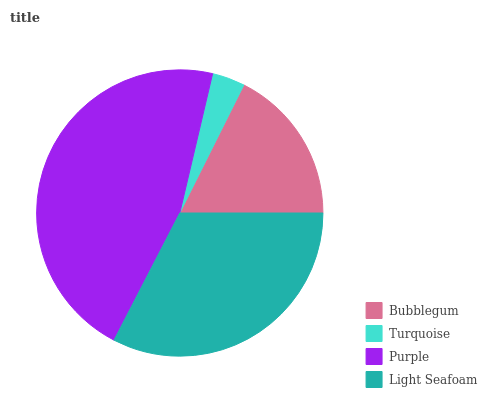Is Turquoise the minimum?
Answer yes or no. Yes. Is Purple the maximum?
Answer yes or no. Yes. Is Purple the minimum?
Answer yes or no. No. Is Turquoise the maximum?
Answer yes or no. No. Is Purple greater than Turquoise?
Answer yes or no. Yes. Is Turquoise less than Purple?
Answer yes or no. Yes. Is Turquoise greater than Purple?
Answer yes or no. No. Is Purple less than Turquoise?
Answer yes or no. No. Is Light Seafoam the high median?
Answer yes or no. Yes. Is Bubblegum the low median?
Answer yes or no. Yes. Is Turquoise the high median?
Answer yes or no. No. Is Purple the low median?
Answer yes or no. No. 